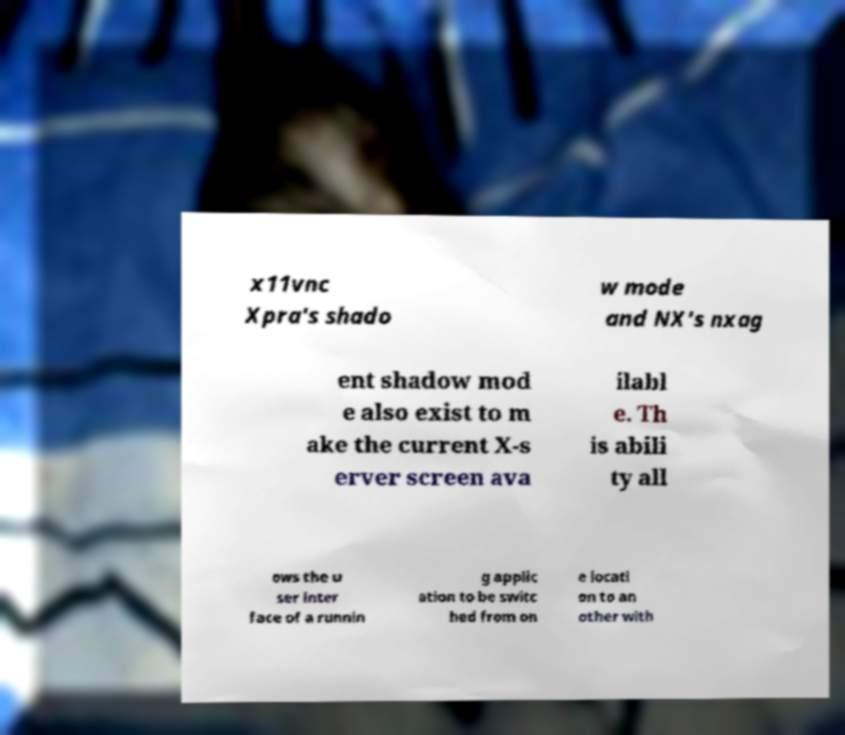What messages or text are displayed in this image? I need them in a readable, typed format. x11vnc Xpra's shado w mode and NX's nxag ent shadow mod e also exist to m ake the current X-s erver screen ava ilabl e. Th is abili ty all ows the u ser inter face of a runnin g applic ation to be switc hed from on e locati on to an other with 